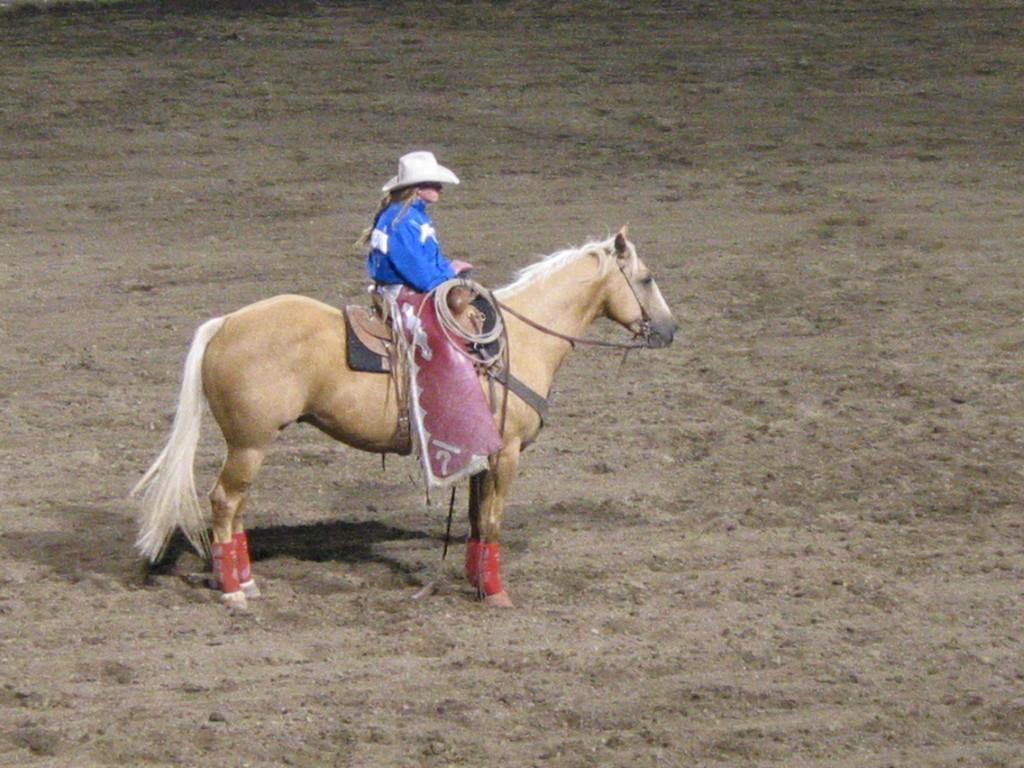What is the main subject of the image? There is a person in the image. What is the person doing in the image? The person is sitting on a horse. Can you describe the horse in the image? The horse is brown in color. What type of tin can be seen on the horse's back in the image? There is no tin present on the horse's back in the image. 